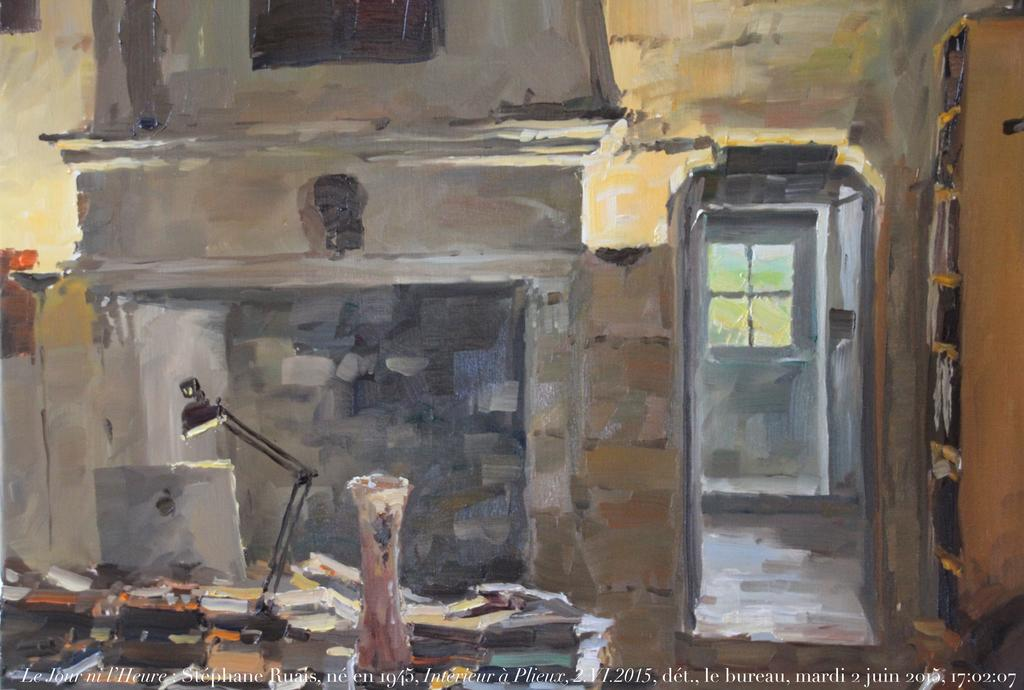What type of items can be seen in the image? There are books in the image. What is used to store the books in the image? There is a shelf in the image. What else can be found in the image besides books and the shelf? There are objects in the image. Can you identify any written content in the image? Yes, there is text in the image. Are there any numerical elements in the image? Yes, there are numbers in the image. What type of pipe is visible in the image? There is no pipe present in the image. How many babies are visible in the image? There are no babies present in the image. 